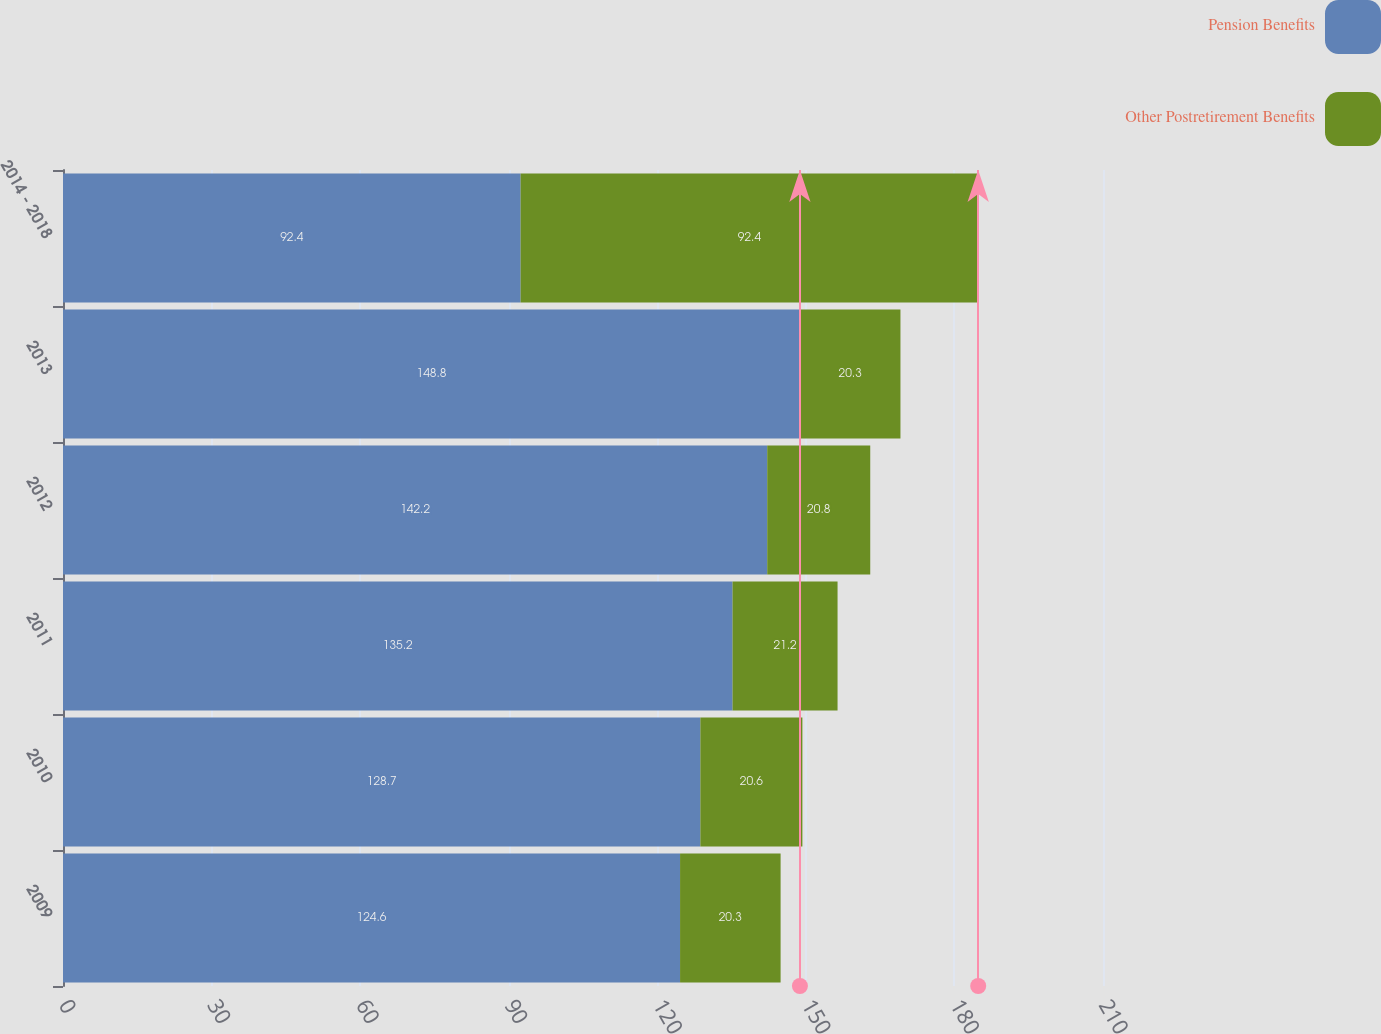Convert chart. <chart><loc_0><loc_0><loc_500><loc_500><stacked_bar_chart><ecel><fcel>2009<fcel>2010<fcel>2011<fcel>2012<fcel>2013<fcel>2014 - 2018<nl><fcel>Pension Benefits<fcel>124.6<fcel>128.7<fcel>135.2<fcel>142.2<fcel>148.8<fcel>92.4<nl><fcel>Other Postretirement Benefits<fcel>20.3<fcel>20.6<fcel>21.2<fcel>20.8<fcel>20.3<fcel>92.4<nl></chart> 